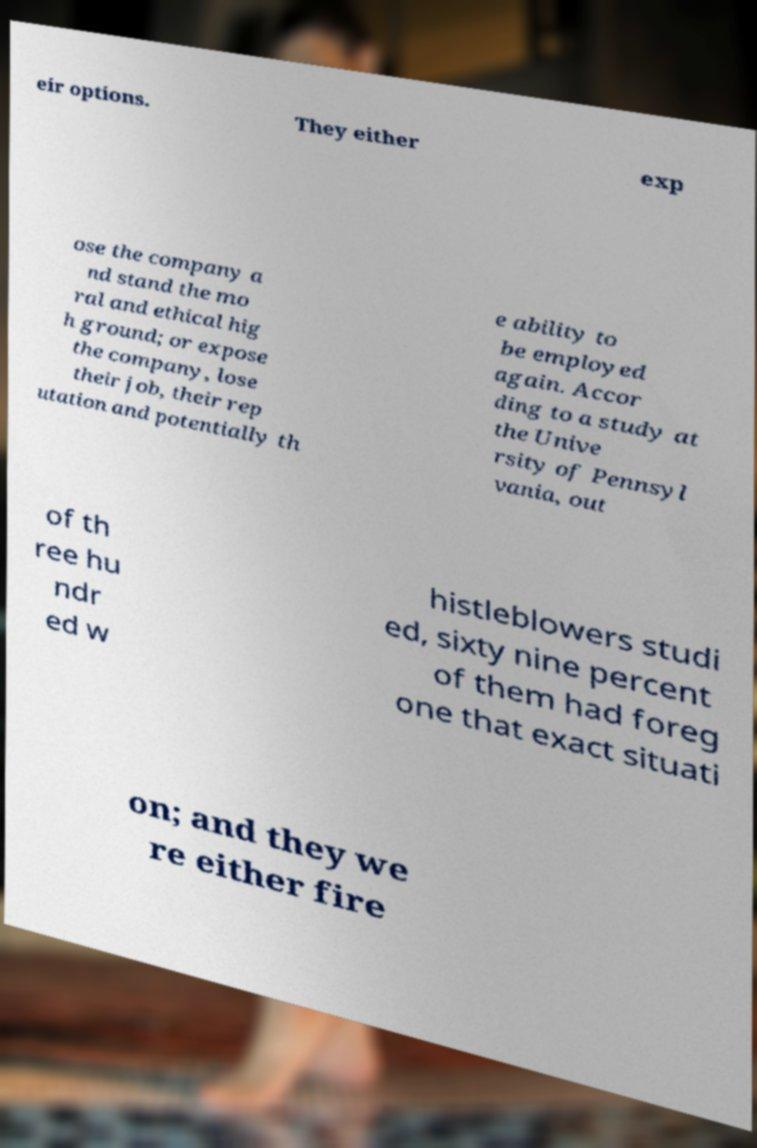Please read and relay the text visible in this image. What does it say? eir options. They either exp ose the company a nd stand the mo ral and ethical hig h ground; or expose the company, lose their job, their rep utation and potentially th e ability to be employed again. Accor ding to a study at the Unive rsity of Pennsyl vania, out of th ree hu ndr ed w histleblowers studi ed, sixty nine percent of them had foreg one that exact situati on; and they we re either fire 